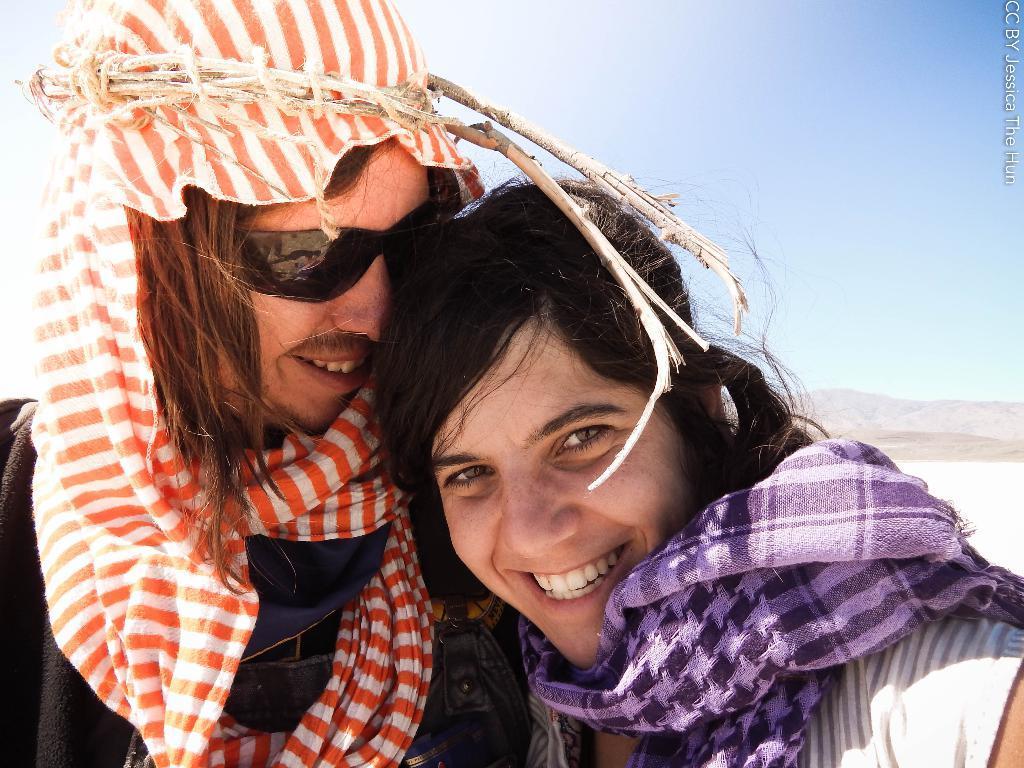Describe this image in one or two sentences. Here we can see a woman and a man. They are smiling and he has goggles. In the background we can see a mountain and sky. 